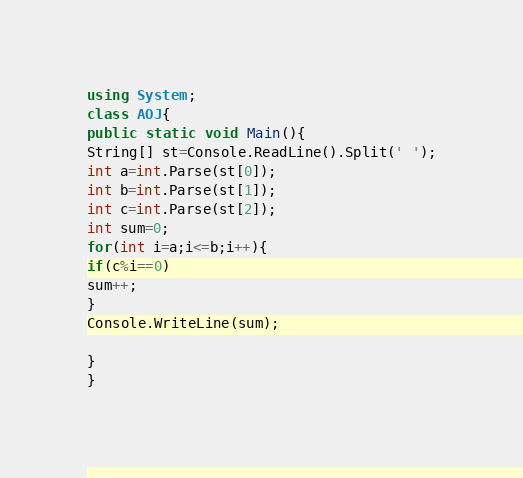Convert code to text. <code><loc_0><loc_0><loc_500><loc_500><_C#_>using System;
class AOJ{
public static void Main(){
String[] st=Console.ReadLine().Split(' ');
int a=int.Parse(st[0]);
int b=int.Parse(st[1]);
int c=int.Parse(st[2]);
int sum=0;
for(int i=a;i<=b;i++){
if(c%i==0)
sum++;
}
Console.WriteLine(sum);

}
}</code> 